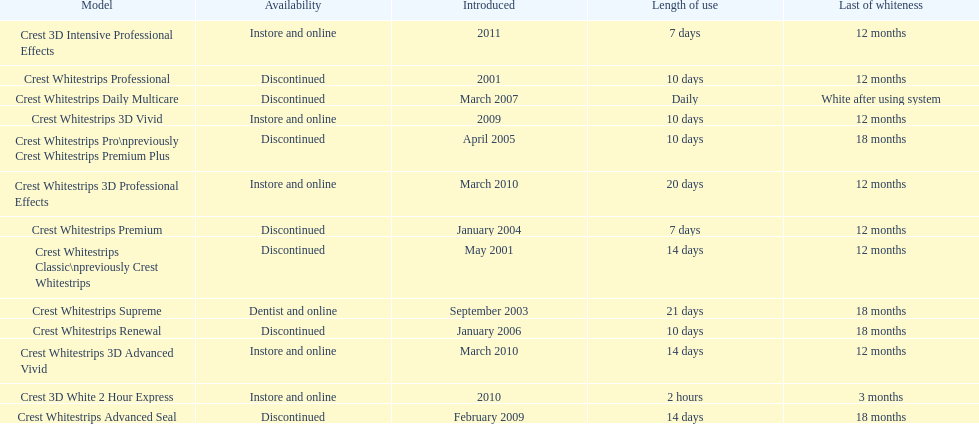How many products have been discontinued? 7. Could you help me parse every detail presented in this table? {'header': ['Model', 'Availability', 'Introduced', 'Length of use', 'Last of whiteness'], 'rows': [['Crest 3D Intensive Professional Effects', 'Instore and online', '2011', '7 days', '12 months'], ['Crest Whitestrips Professional', 'Discontinued', '2001', '10 days', '12 months'], ['Crest Whitestrips Daily Multicare', 'Discontinued', 'March 2007', 'Daily', 'White after using system'], ['Crest Whitestrips 3D Vivid', 'Instore and online', '2009', '10 days', '12 months'], ['Crest Whitestrips Pro\\npreviously Crest Whitestrips Premium Plus', 'Discontinued', 'April 2005', '10 days', '18 months'], ['Crest Whitestrips 3D Professional Effects', 'Instore and online', 'March 2010', '20 days', '12 months'], ['Crest Whitestrips Premium', 'Discontinued', 'January 2004', '7 days', '12 months'], ['Crest Whitestrips Classic\\npreviously Crest Whitestrips', 'Discontinued', 'May 2001', '14 days', '12 months'], ['Crest Whitestrips Supreme', 'Dentist and online', 'September 2003', '21 days', '18 months'], ['Crest Whitestrips Renewal', 'Discontinued', 'January 2006', '10 days', '18 months'], ['Crest Whitestrips 3D Advanced Vivid', 'Instore and online', 'March 2010', '14 days', '12 months'], ['Crest 3D White 2 Hour Express', 'Instore and online', '2010', '2 hours', '3 months'], ['Crest Whitestrips Advanced Seal', 'Discontinued', 'February 2009', '14 days', '18 months']]} 